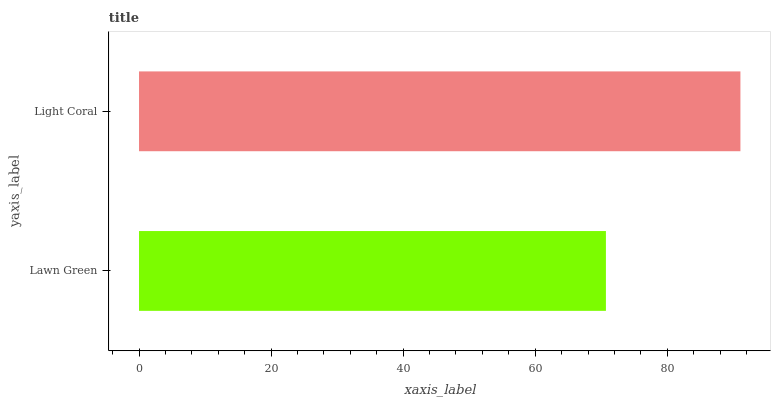Is Lawn Green the minimum?
Answer yes or no. Yes. Is Light Coral the maximum?
Answer yes or no. Yes. Is Light Coral the minimum?
Answer yes or no. No. Is Light Coral greater than Lawn Green?
Answer yes or no. Yes. Is Lawn Green less than Light Coral?
Answer yes or no. Yes. Is Lawn Green greater than Light Coral?
Answer yes or no. No. Is Light Coral less than Lawn Green?
Answer yes or no. No. Is Light Coral the high median?
Answer yes or no. Yes. Is Lawn Green the low median?
Answer yes or no. Yes. Is Lawn Green the high median?
Answer yes or no. No. Is Light Coral the low median?
Answer yes or no. No. 